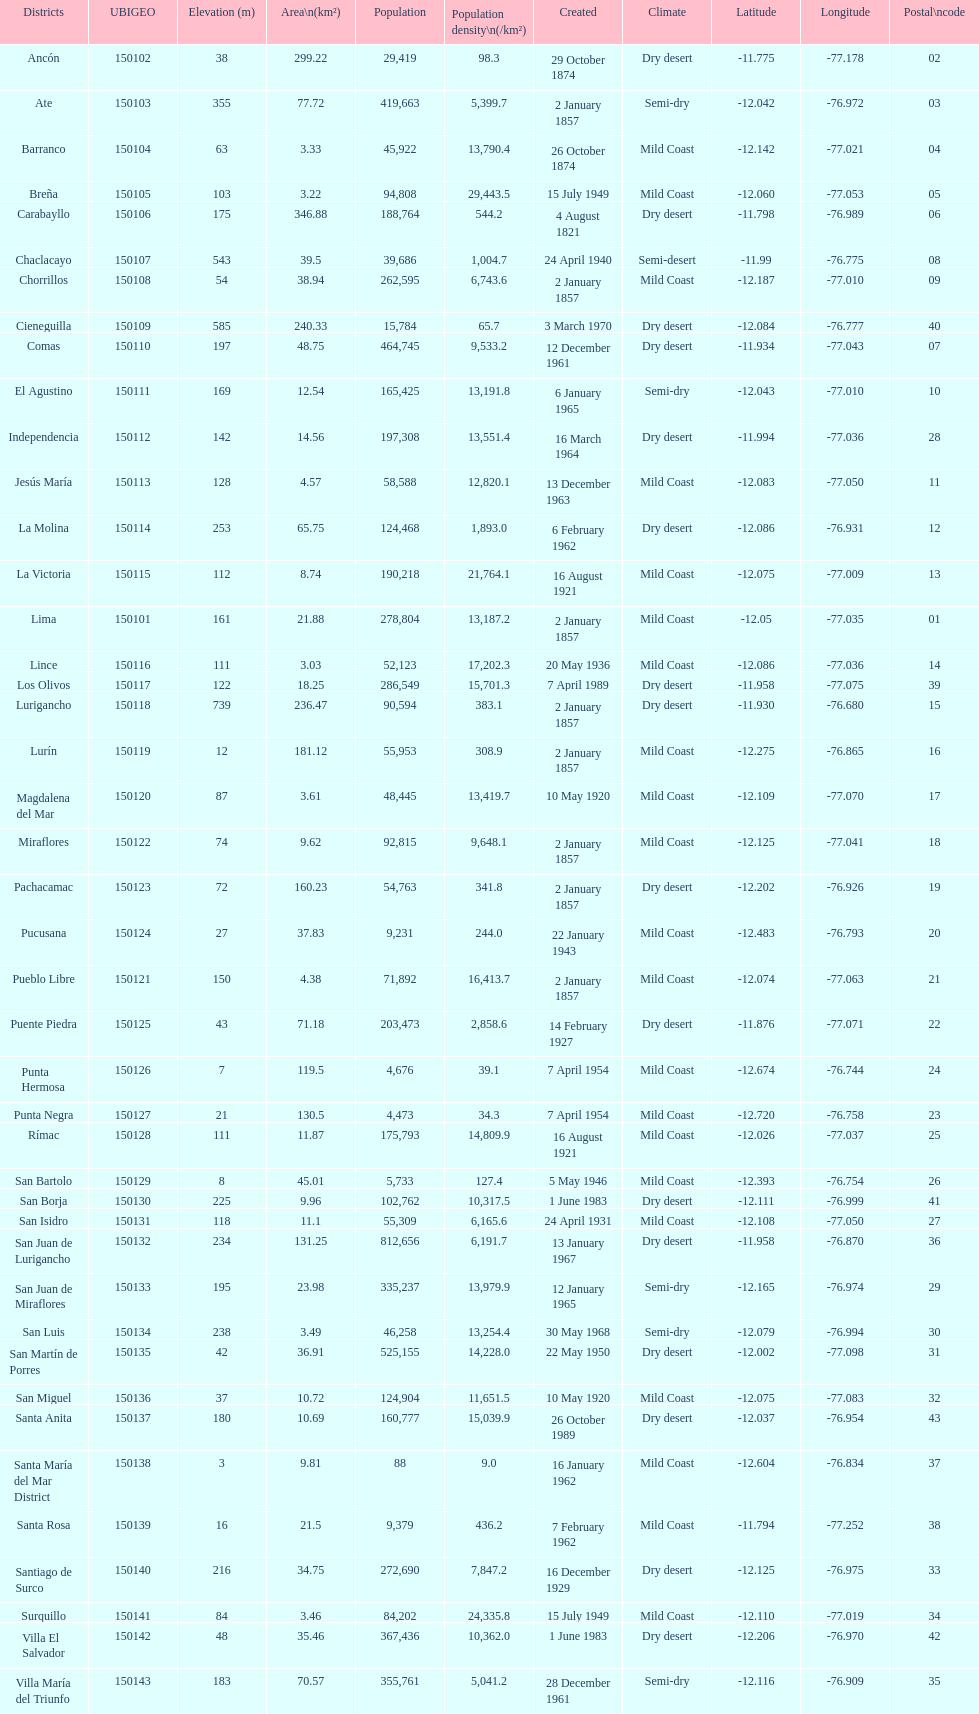How many districts have more than 100,000 people in this city? 21. Could you help me parse every detail presented in this table? {'header': ['Districts', 'UBIGEO', 'Elevation (m)', 'Area\\n(km²)', 'Population', 'Population density\\n(/km²)', 'Created', 'Climate', 'Latitude', 'Longitude', 'Postal\\ncode'], 'rows': [['Ancón', '150102', '38', '299.22', '29,419', '98.3', '29 October 1874', 'Dry desert', '-11.775', '-77.178', '02'], ['Ate', '150103', '355', '77.72', '419,663', '5,399.7', '2 January 1857', 'Semi-dry', '-12.042', '-76.972', '03'], ['Barranco', '150104', '63', '3.33', '45,922', '13,790.4', '26 October 1874', 'Mild Coast', '-12.142', '-77.021', '04'], ['Breña', '150105', '103', '3.22', '94,808', '29,443.5', '15 July 1949', 'Mild Coast', '-12.060', '-77.053', '05'], ['Carabayllo', '150106', '175', '346.88', '188,764', '544.2', '4 August 1821', 'Dry desert', '-11.798', '-76.989', '06'], ['Chaclacayo', '150107', '543', '39.5', '39,686', '1,004.7', '24 April 1940', 'Semi-desert', '-11.99', '-76.775', '08'], ['Chorrillos', '150108', '54', '38.94', '262,595', '6,743.6', '2 January 1857', 'Mild Coast', '-12.187', '-77.010', '09'], ['Cieneguilla', '150109', '585', '240.33', '15,784', '65.7', '3 March 1970', 'Dry desert', '-12.084', '-76.777', '40'], ['Comas', '150110', '197', '48.75', '464,745', '9,533.2', '12 December 1961', 'Dry desert', '-11.934', '-77.043', '07'], ['El Agustino', '150111', '169', '12.54', '165,425', '13,191.8', '6 January 1965', 'Semi-dry', '-12.043', '-77.010', '10'], ['Independencia', '150112', '142', '14.56', '197,308', '13,551.4', '16 March 1964', 'Dry desert', '-11.994', '-77.036', '28'], ['Jesús María', '150113', '128', '4.57', '58,588', '12,820.1', '13 December 1963', 'Mild Coast', '-12.083', '-77.050', '11'], ['La Molina', '150114', '253', '65.75', '124,468', '1,893.0', '6 February 1962', 'Dry desert', '-12.086', '-76.931', '12'], ['La Victoria', '150115', '112', '8.74', '190,218', '21,764.1', '16 August 1921', 'Mild Coast', '-12.075', '-77.009', '13'], ['Lima', '150101', '161', '21.88', '278,804', '13,187.2', '2 January 1857', 'Mild Coast', '-12.05', '-77.035', '01'], ['Lince', '150116', '111', '3.03', '52,123', '17,202.3', '20 May 1936', 'Mild Coast', '-12.086', '-77.036', '14'], ['Los Olivos', '150117', '122', '18.25', '286,549', '15,701.3', '7 April 1989', 'Dry desert', '-11.958', '-77.075', '39'], ['Lurigancho', '150118', '739', '236.47', '90,594', '383.1', '2 January 1857', 'Dry desert', '-11.930', '-76.680', '15'], ['Lurín', '150119', '12', '181.12', '55,953', '308.9', '2 January 1857', 'Mild Coast', '-12.275', '-76.865', '16'], ['Magdalena del Mar', '150120', '87', '3.61', '48,445', '13,419.7', '10 May 1920', 'Mild Coast', '-12.109', '-77.070', '17'], ['Miraflores', '150122', '74', '9.62', '92,815', '9,648.1', '2 January 1857', 'Mild Coast', '-12.125', '-77.041', '18'], ['Pachacamac', '150123', '72', '160.23', '54,763', '341.8', '2 January 1857', 'Dry desert', '-12.202', '-76.926', '19'], ['Pucusana', '150124', '27', '37.83', '9,231', '244.0', '22 January 1943', 'Mild Coast', '-12.483', '-76.793', '20'], ['Pueblo Libre', '150121', '150', '4.38', '71,892', '16,413.7', '2 January 1857', 'Mild Coast', '-12.074', '-77.063', '21'], ['Puente Piedra', '150125', '43', '71.18', '203,473', '2,858.6', '14 February 1927', 'Dry desert', '-11.876', '-77.071', '22'], ['Punta Hermosa', '150126', '7', '119.5', '4,676', '39.1', '7 April 1954', 'Mild Coast', '-12.674', '-76.744', '24'], ['Punta Negra', '150127', '21', '130.5', '4,473', '34.3', '7 April 1954', 'Mild Coast', '-12.720', '-76.758', '23'], ['Rímac', '150128', '111', '11.87', '175,793', '14,809.9', '16 August 1921', 'Mild Coast', '-12.026', '-77.037', '25'], ['San Bartolo', '150129', '8', '45.01', '5,733', '127.4', '5 May 1946', 'Mild Coast', '-12.393', '-76.754', '26'], ['San Borja', '150130', '225', '9.96', '102,762', '10,317.5', '1 June 1983', 'Dry desert', '-12.111', '-76.999', '41'], ['San Isidro', '150131', '118', '11.1', '55,309', '6,165.6', '24 April 1931', 'Mild Coast', '-12.108', '-77.050', '27'], ['San Juan de Lurigancho', '150132', '234', '131.25', '812,656', '6,191.7', '13 January 1967', 'Dry desert', '-11.958', '-76.870', '36'], ['San Juan de Miraflores', '150133', '195', '23.98', '335,237', '13,979.9', '12 January 1965', 'Semi-dry', '-12.165', '-76.974', '29'], ['San Luis', '150134', '238', '3.49', '46,258', '13,254.4', '30 May 1968', 'Semi-dry', '-12.079', '-76.994', '30'], ['San Martín de Porres', '150135', '42', '36.91', '525,155', '14,228.0', '22 May 1950', 'Dry desert', '-12.002', '-77.098', '31'], ['San Miguel', '150136', '37', '10.72', '124,904', '11,651.5', '10 May 1920', 'Mild Coast', '-12.075', '-77.083', '32'], ['Santa Anita', '150137', '180', '10.69', '160,777', '15,039.9', '26 October 1989', 'Dry desert', '-12.037', '-76.954', '43'], ['Santa María del Mar District', '150138', '3', '9.81', '88', '9.0', '16 January 1962', 'Mild Coast', '-12.604', '-76.834', '37'], ['Santa Rosa', '150139', '16', '21.5', '9,379', '436.2', '7 February 1962', 'Mild Coast', '-11.794', '-77.252', '38'], ['Santiago de Surco', '150140', '216', '34.75', '272,690', '7,847.2', '16 December 1929', 'Dry desert', '-12.125', '-76.975', '33'], ['Surquillo', '150141', '84', '3.46', '84,202', '24,335.8', '15 July 1949', 'Mild Coast', '-12.110', '-77.019', '34'], ['Villa El Salvador', '150142', '48', '35.46', '367,436', '10,362.0', '1 June 1983', 'Dry desert', '-12.206', '-76.970', '42'], ['Villa María del Triunfo', '150143', '183', '70.57', '355,761', '5,041.2', '28 December 1961', 'Semi-dry', '-12.116', '-76.909', '35']]} 